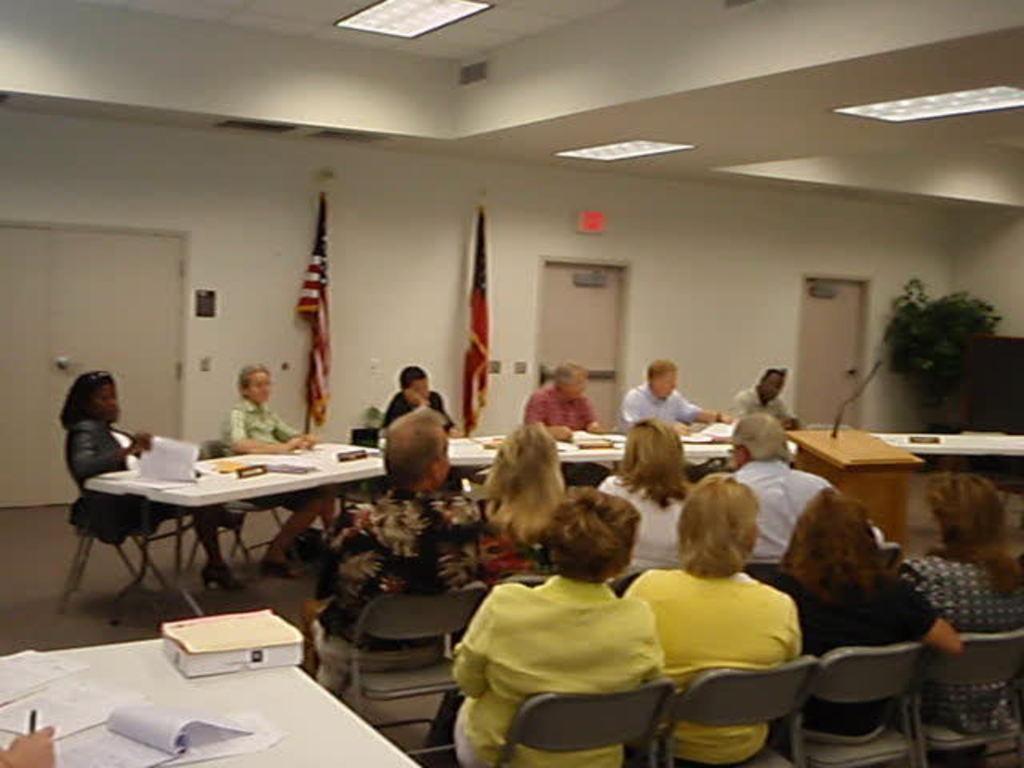In one or two sentences, can you explain what this image depicts? In this image there are people sitting on chairs which are near to the table. On the table there are papers,books,board. At the background there is a wall and a flag in front of the wall. At the top there is ceiling and lights. At the right corner there is a tree. There is a podium in front of people who are sitting in the chairs. 